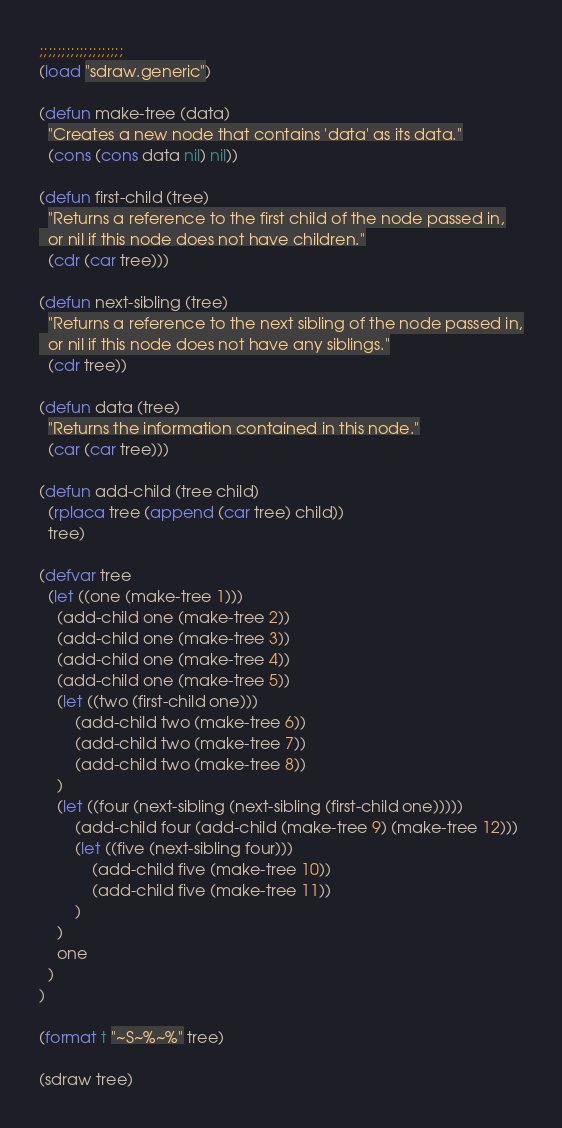Convert code to text. <code><loc_0><loc_0><loc_500><loc_500><_Lisp_>;;;;;;;;;;;;;;;;;;;
(load "sdraw.generic")

(defun make-tree (data)
  "Creates a new node that contains 'data' as its data."
  (cons (cons data nil) nil))

(defun first-child (tree)
  "Returns a reference to the first child of the node passed in,
  or nil if this node does not have children."
  (cdr (car tree)))

(defun next-sibling (tree)
  "Returns a reference to the next sibling of the node passed in,
  or nil if this node does not have any siblings."
  (cdr tree))

(defun data (tree)
  "Returns the information contained in this node."
  (car (car tree)))

(defun add-child (tree child)
  (rplaca tree (append (car tree) child))
  tree)

(defvar tree 
  (let ((one (make-tree 1)))
    (add-child one (make-tree 2))
    (add-child one (make-tree 3))
    (add-child one (make-tree 4))
    (add-child one (make-tree 5))
    (let ((two (first-child one)))
        (add-child two (make-tree 6))
        (add-child two (make-tree 7))
        (add-child two (make-tree 8))
    )
    (let ((four (next-sibling (next-sibling (first-child one)))))
        (add-child four (add-child (make-tree 9) (make-tree 12)))
        (let ((five (next-sibling four)))
            (add-child five (make-tree 10))
            (add-child five (make-tree 11))
        )
    )
    one
  )
)

(format t "~S~%~%" tree)

(sdraw tree)
</code> 